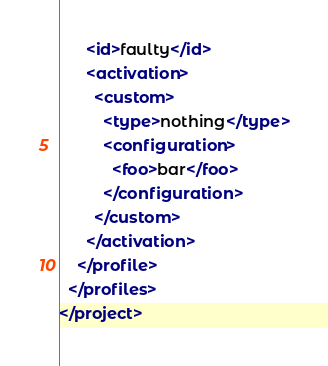<code> <loc_0><loc_0><loc_500><loc_500><_XML_>      <id>faulty</id>
      <activation>
        <custom>
          <type>nothing</type>
          <configuration>
            <foo>bar</foo>
          </configuration>
        </custom>
      </activation>
    </profile>
  </profiles>
</project>
</code> 